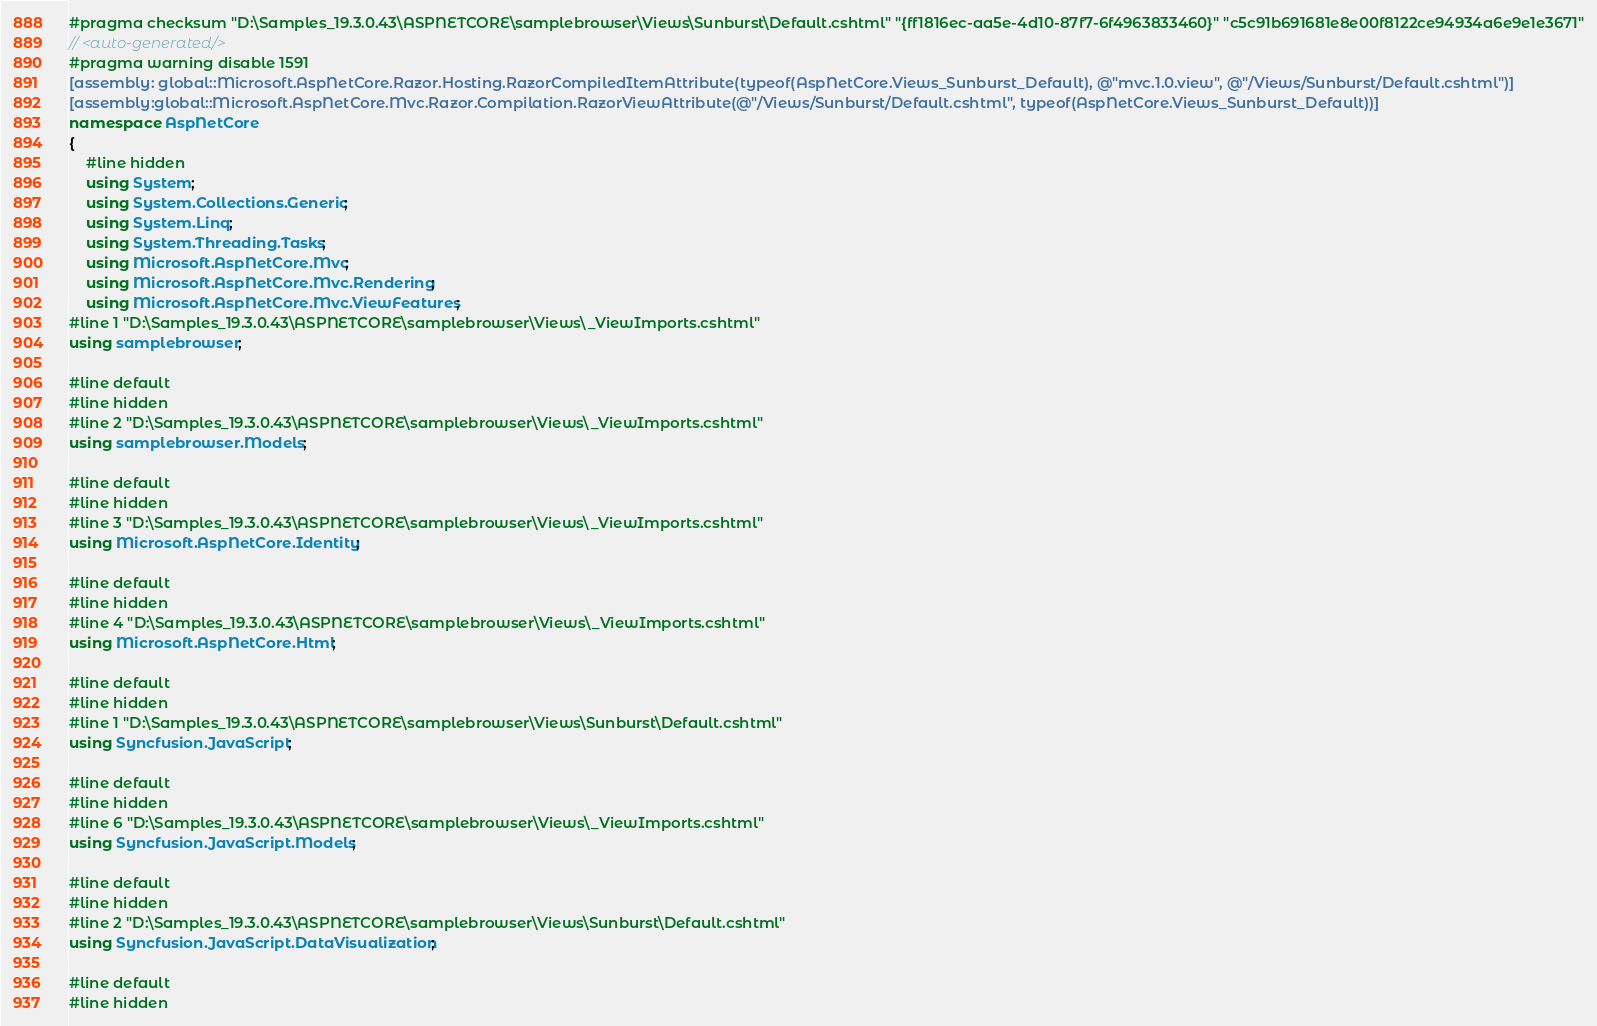<code> <loc_0><loc_0><loc_500><loc_500><_C#_>#pragma checksum "D:\Samples_19.3.0.43\ASPNETCORE\samplebrowser\Views\Sunburst\Default.cshtml" "{ff1816ec-aa5e-4d10-87f7-6f4963833460}" "c5c91b691681e8e00f8122ce94934a6e9e1e3671"
// <auto-generated/>
#pragma warning disable 1591
[assembly: global::Microsoft.AspNetCore.Razor.Hosting.RazorCompiledItemAttribute(typeof(AspNetCore.Views_Sunburst_Default), @"mvc.1.0.view", @"/Views/Sunburst/Default.cshtml")]
[assembly:global::Microsoft.AspNetCore.Mvc.Razor.Compilation.RazorViewAttribute(@"/Views/Sunburst/Default.cshtml", typeof(AspNetCore.Views_Sunburst_Default))]
namespace AspNetCore
{
    #line hidden
    using System;
    using System.Collections.Generic;
    using System.Linq;
    using System.Threading.Tasks;
    using Microsoft.AspNetCore.Mvc;
    using Microsoft.AspNetCore.Mvc.Rendering;
    using Microsoft.AspNetCore.Mvc.ViewFeatures;
#line 1 "D:\Samples_19.3.0.43\ASPNETCORE\samplebrowser\Views\_ViewImports.cshtml"
using samplebrowser;

#line default
#line hidden
#line 2 "D:\Samples_19.3.0.43\ASPNETCORE\samplebrowser\Views\_ViewImports.cshtml"
using samplebrowser.Models;

#line default
#line hidden
#line 3 "D:\Samples_19.3.0.43\ASPNETCORE\samplebrowser\Views\_ViewImports.cshtml"
using Microsoft.AspNetCore.Identity;

#line default
#line hidden
#line 4 "D:\Samples_19.3.0.43\ASPNETCORE\samplebrowser\Views\_ViewImports.cshtml"
using Microsoft.AspNetCore.Html;

#line default
#line hidden
#line 1 "D:\Samples_19.3.0.43\ASPNETCORE\samplebrowser\Views\Sunburst\Default.cshtml"
using Syncfusion.JavaScript;

#line default
#line hidden
#line 6 "D:\Samples_19.3.0.43\ASPNETCORE\samplebrowser\Views\_ViewImports.cshtml"
using Syncfusion.JavaScript.Models;

#line default
#line hidden
#line 2 "D:\Samples_19.3.0.43\ASPNETCORE\samplebrowser\Views\Sunburst\Default.cshtml"
using Syncfusion.JavaScript.DataVisualization;

#line default
#line hidden</code> 